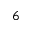<formula> <loc_0><loc_0><loc_500><loc_500>^ { 6 }</formula> 